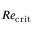Convert formula to latex. <formula><loc_0><loc_0><loc_500><loc_500>R e _ { c r i t }</formula> 